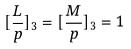<formula> <loc_0><loc_0><loc_500><loc_500>[ \frac { L } { p } ] _ { 3 } = [ \frac { M } { p } ] _ { 3 } = 1</formula> 